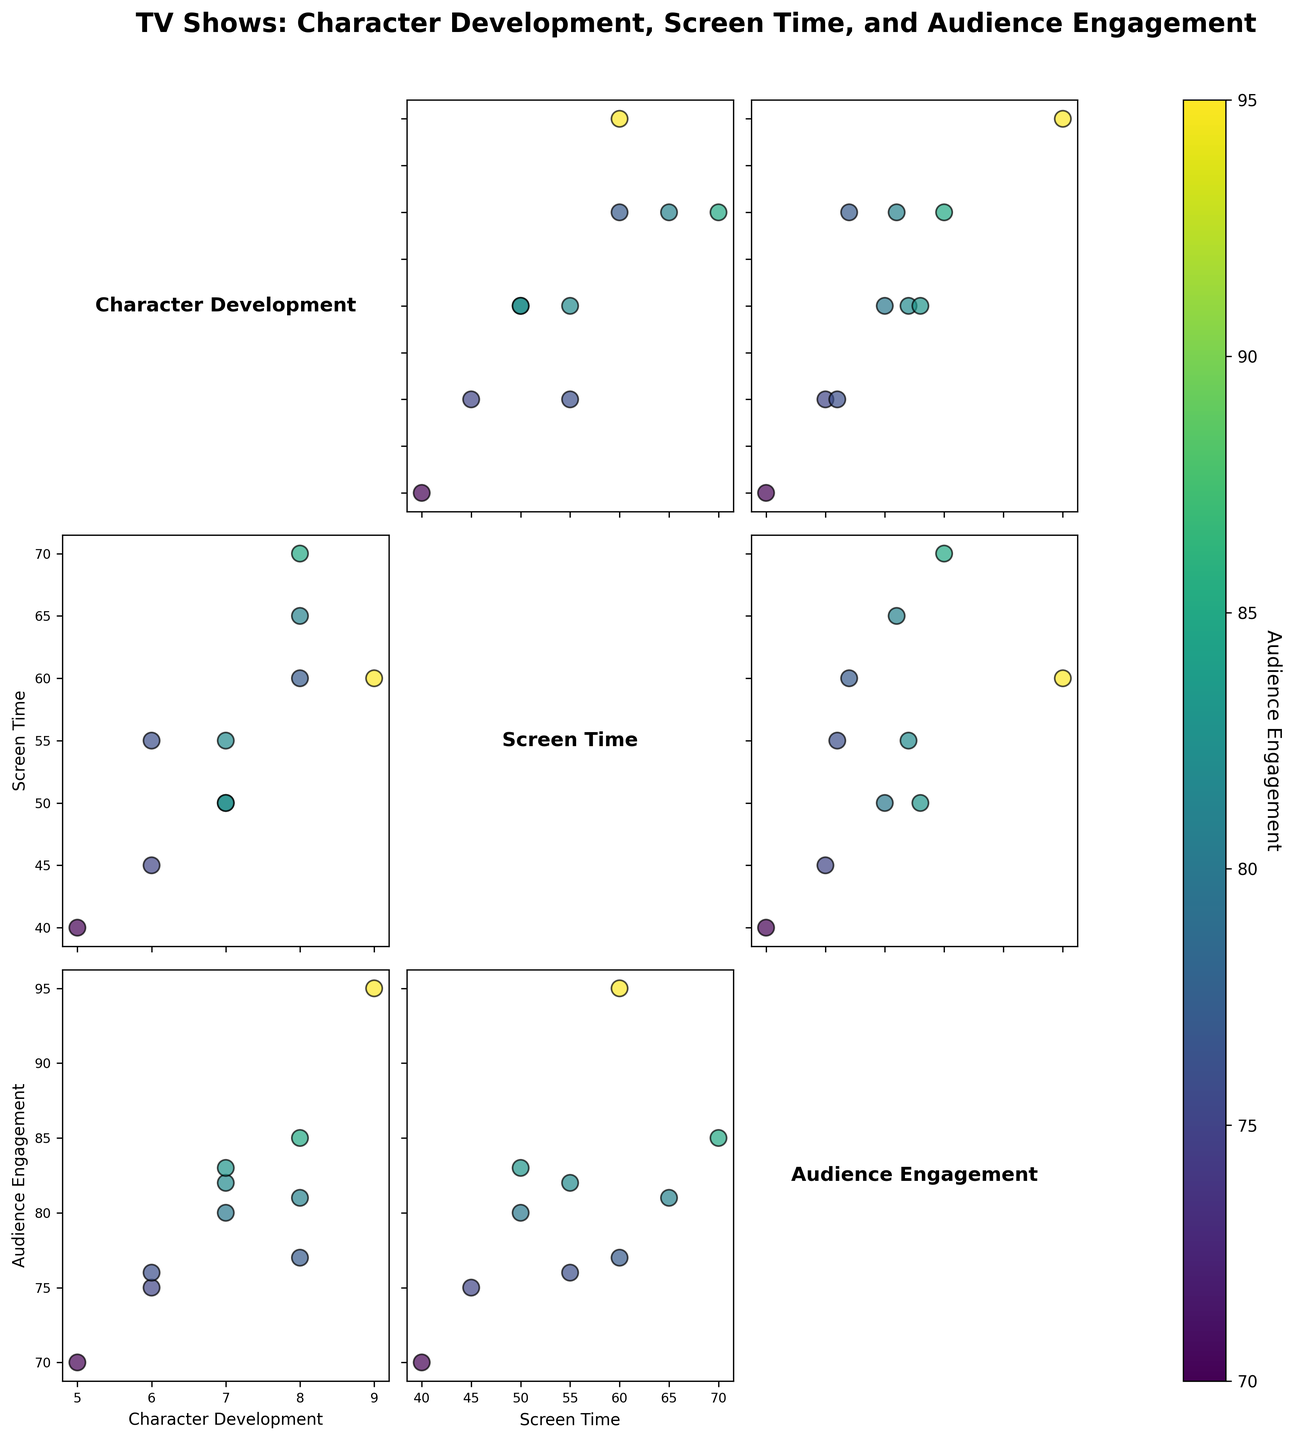How is 'Game of Thrones' portrayed in the scatter plot comparing 'Character Development' and 'Screen Time'? Locate the point corresponding to 'Game of Thrones' on the scatter plot comparing 'Character Development' and 'Screen Time'. It should be at coordinates (8, 70).
Answer: (8, 70) Which TV show has the highest 'Audience Engagement'? Find the point with the highest value on the color bar for 'Audience Engagement'. 'Breaking Bad', whose data point appears brightest, has the highest engagement at 95.
Answer: Breaking Bad Is there a positive correlation between 'Screen Time' and 'Audience Engagement'? Check if points generally trend upwards from left to right on the scatter plot comparing 'Screen Time' and 'Audience Engagement'. Points seem to incline upwards, suggesting a positive correlation.
Answer: Yes What TV shows are clustered around a 'Character Development' score of 7? Identify the scatter points near 7 on the Character Development axis. 'Stranger Things', 'The Mandalorian', and 'The Witcher' cluster here.
Answer: Stranger Things, The Mandalorian, The Witcher If a TV show has 60 minutes of 'Screen Time', how does its 'Character Development' score vary? Look at the scatter plot comparing 'Screen Time' and 'Character Development' for points at 60. 'Character Development' scores vary from 8 to 9 for 60 minutes of 'Screen Time'.
Answer: 8 to 9 Which axis uses 'Audience Engagement' as a parameter in the plot? Audience Engagement is represented in color and not directly as an axis in any scatter plot but is shown in the color bar.
Answer: Color bar Compare 'The Office' and 'Friends' in terms of 'Screen Time' and 'Character Development'. Which show is better in both criteria? Refer to the scatter plots and locate both shows. 'The Office' is at (45, 6) and 'Friends' is at (40, 5). 'The Office' has higher values in both metrics.
Answer: The Office What's the average 'Character Development' score across all shows? Sum all Character Development scores (9+8+7+6+5+7+8+7+8+6) = 71. There are 10 shows, so average is 71/10.
Answer: 7.1 Do shows with high 'Character Development' always have high 'Audience Engagement'? Check the scatter between 'Character Development' and 'Audience Engagement'. While many high 'Character Development' shows have high engagement, it is not always true as some deviations exist.
Answer: Not always 